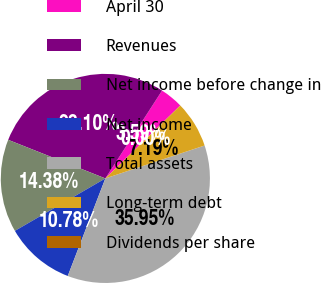Convert chart. <chart><loc_0><loc_0><loc_500><loc_500><pie_chart><fcel>April 30<fcel>Revenues<fcel>Net income before change in<fcel>Net income<fcel>Total assets<fcel>Long-term debt<fcel>Dividends per share<nl><fcel>3.59%<fcel>28.1%<fcel>14.38%<fcel>10.78%<fcel>35.95%<fcel>7.19%<fcel>0.0%<nl></chart> 